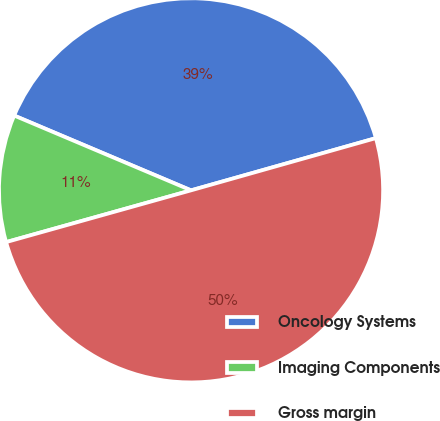Convert chart to OTSL. <chart><loc_0><loc_0><loc_500><loc_500><pie_chart><fcel>Oncology Systems<fcel>Imaging Components<fcel>Gross margin<nl><fcel>39.25%<fcel>10.71%<fcel>50.04%<nl></chart> 